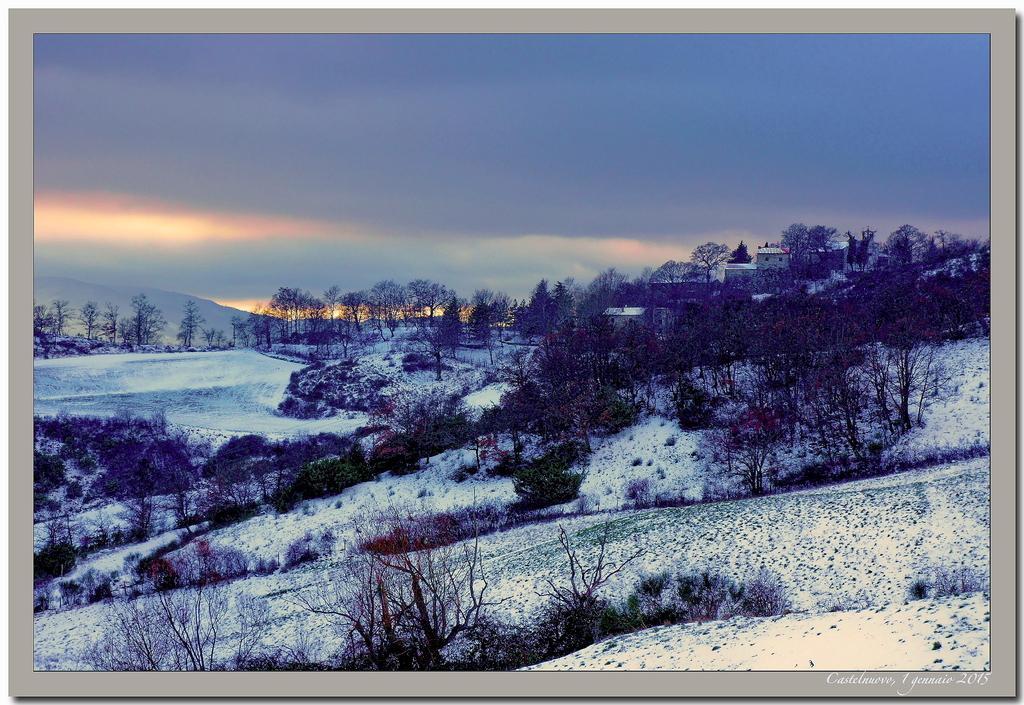Can you describe this image briefly? In this picture we can see trees, buildings, snow, mountains and in the background we can see the sky and at the bottom right corner of this picture we can see some text. 